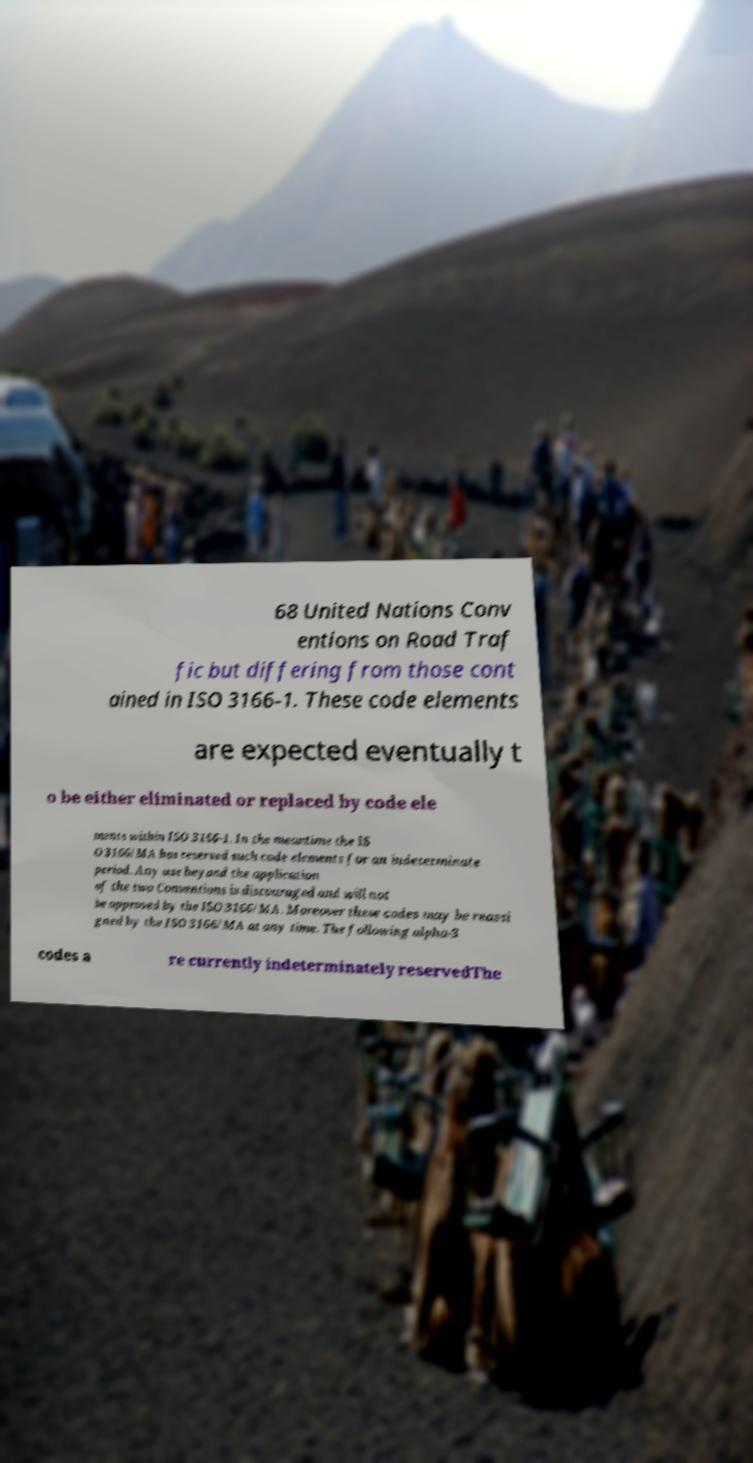Could you extract and type out the text from this image? 68 United Nations Conv entions on Road Traf fic but differing from those cont ained in ISO 3166-1. These code elements are expected eventually t o be either eliminated or replaced by code ele ments within ISO 3166-1. In the meantime the IS O 3166/MA has reserved such code elements for an indeterminate period. Any use beyond the application of the two Conventions is discouraged and will not be approved by the ISO 3166/MA. Moreover these codes may be reassi gned by the ISO 3166/MA at any time. The following alpha-3 codes a re currently indeterminately reservedThe 